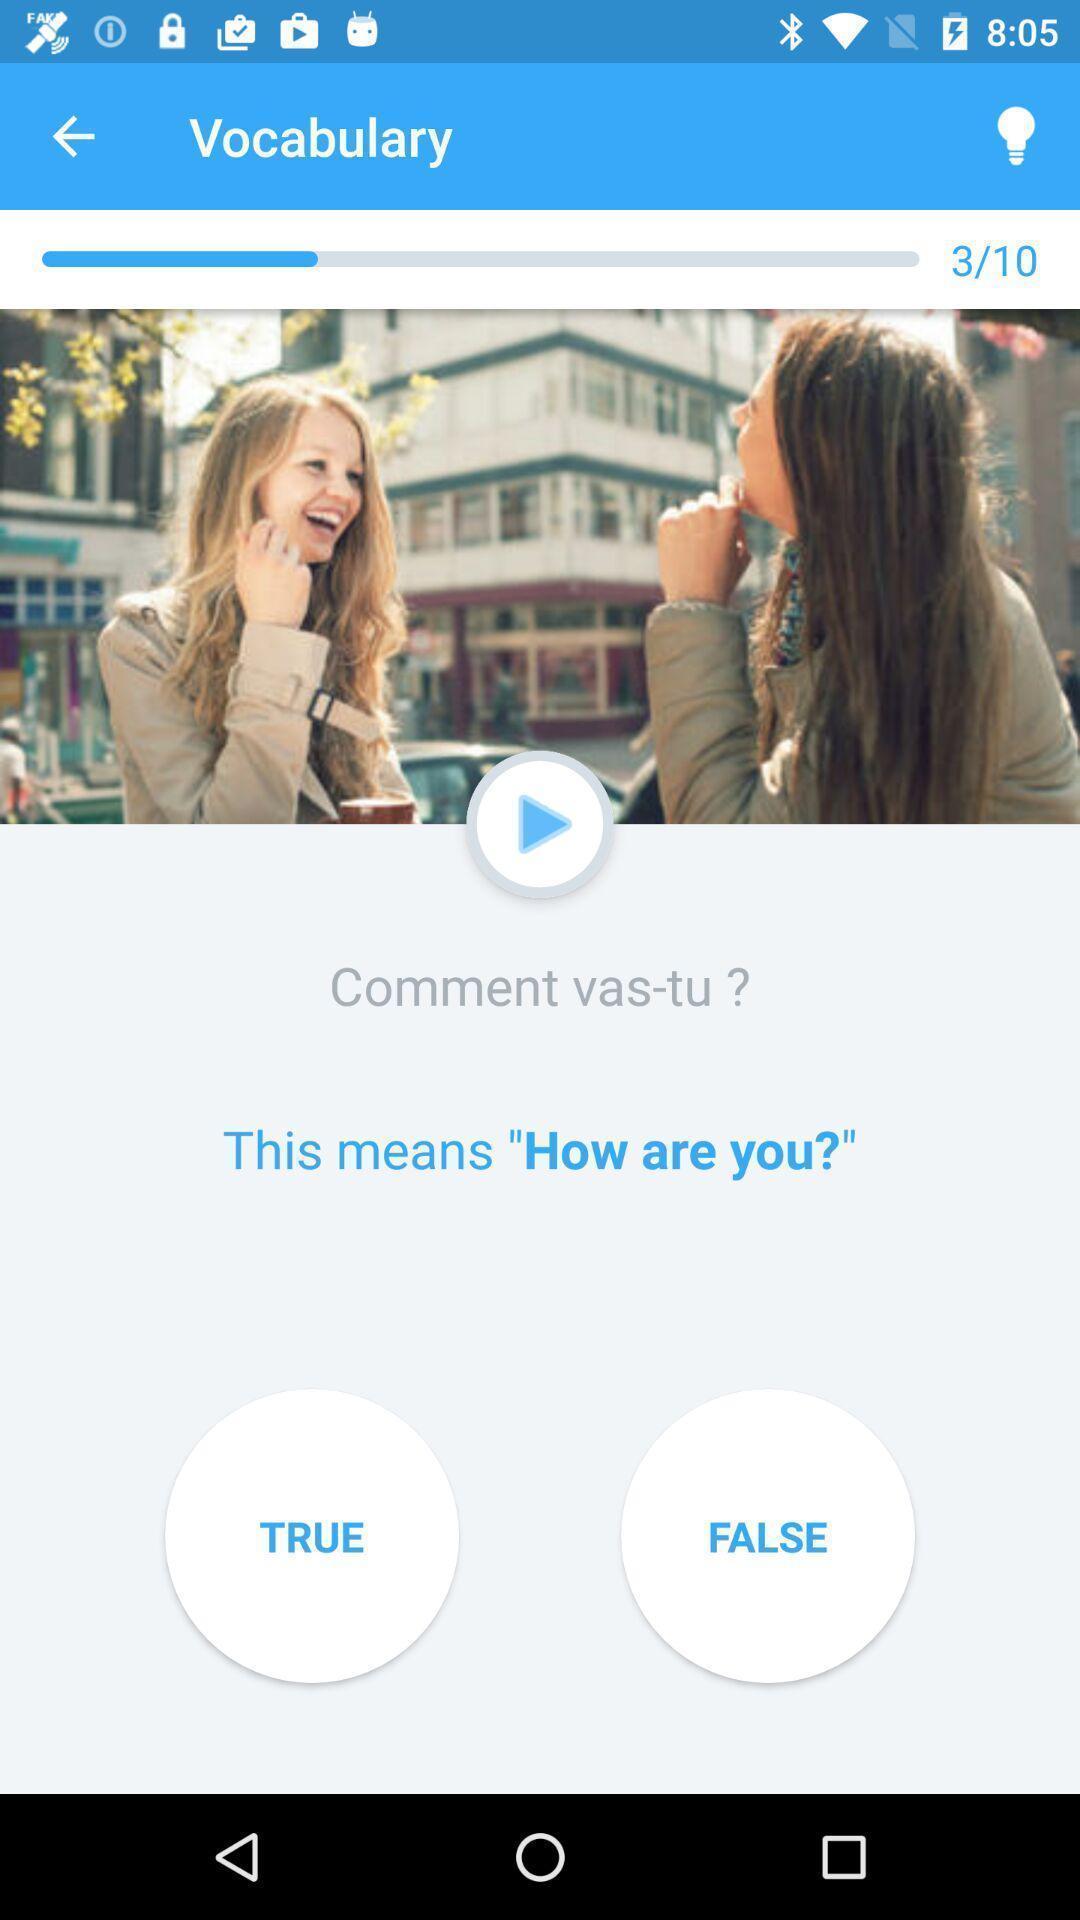What can you discern from this picture? Vocabulary page displayed of a language learning app. 